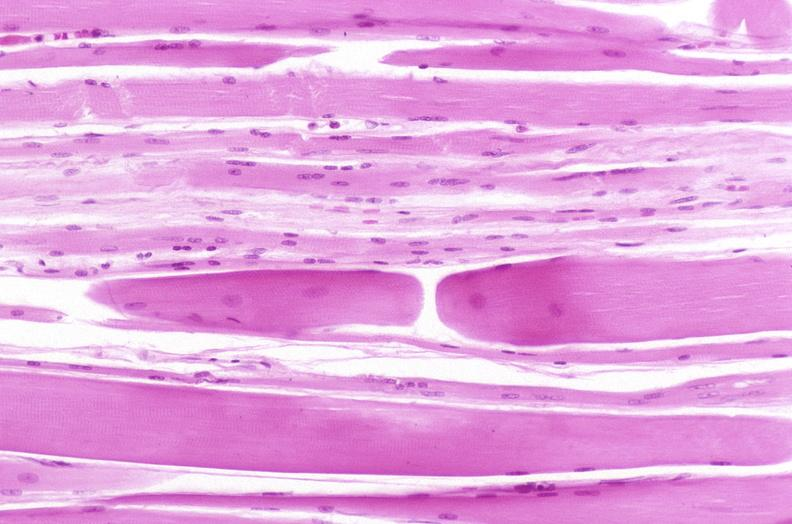s endometritis postpartum present?
Answer the question using a single word or phrase. No 